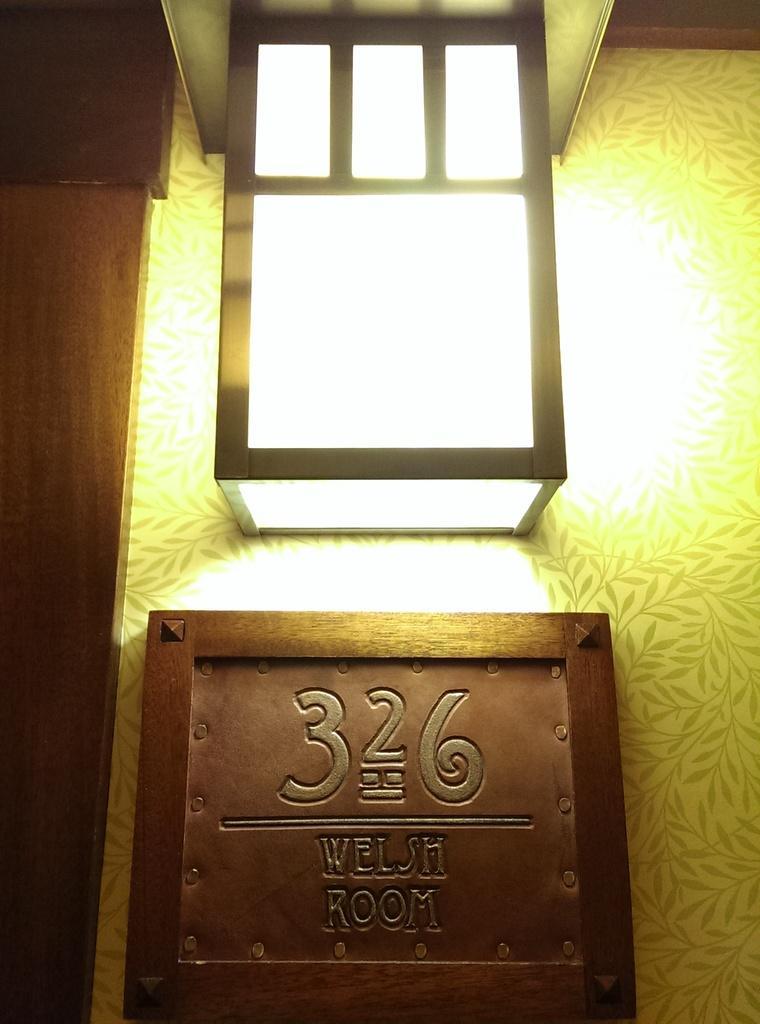In one or two sentences, can you explain what this image depicts? This image consists of light in the middle. There is a board, on which there is ''326 WELSH ROOM'' is at the bottom. 